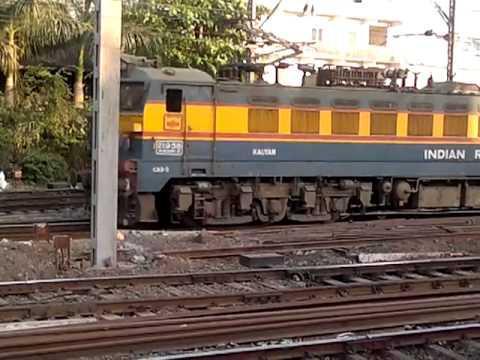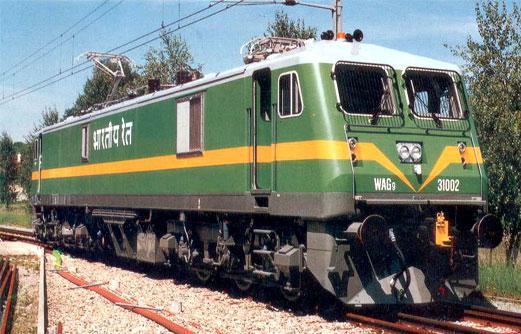The first image is the image on the left, the second image is the image on the right. Examine the images to the left and right. Is the description "The images include exactly one train with a yellow-striped green front car, and it is headed rightward." accurate? Answer yes or no. Yes. The first image is the image on the left, the second image is the image on the right. Examine the images to the left and right. Is the description "The train in the image on the left is moving towards the left." accurate? Answer yes or no. Yes. 